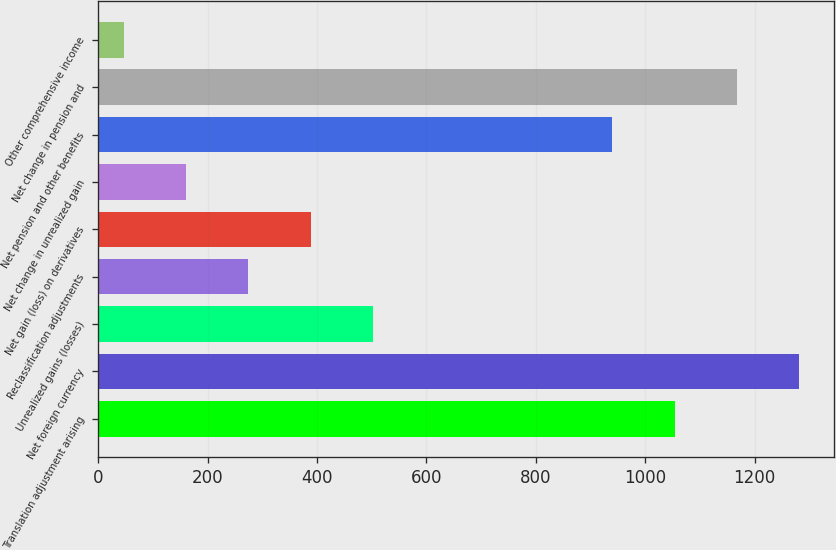Convert chart. <chart><loc_0><loc_0><loc_500><loc_500><bar_chart><fcel>Translation adjustment arising<fcel>Net foreign currency<fcel>Unrealized gains (losses)<fcel>Reclassification adjustments<fcel>Net gain (loss) on derivatives<fcel>Net change in unrealized gain<fcel>Net pension and other benefits<fcel>Net change in pension and<fcel>Other comprehensive income<nl><fcel>1053.7<fcel>1281.1<fcel>501.8<fcel>274.4<fcel>388.1<fcel>160.7<fcel>940<fcel>1167.4<fcel>47<nl></chart> 